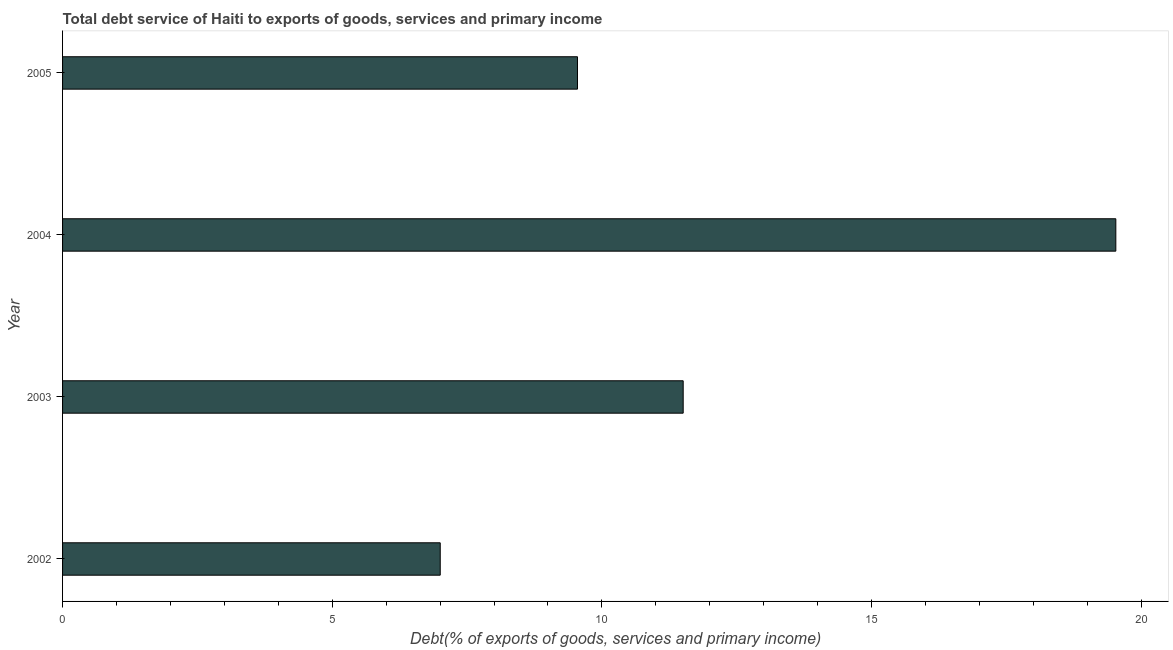Does the graph contain any zero values?
Give a very brief answer. No. What is the title of the graph?
Ensure brevity in your answer.  Total debt service of Haiti to exports of goods, services and primary income. What is the label or title of the X-axis?
Make the answer very short. Debt(% of exports of goods, services and primary income). What is the label or title of the Y-axis?
Give a very brief answer. Year. What is the total debt service in 2003?
Your response must be concise. 11.51. Across all years, what is the maximum total debt service?
Provide a succinct answer. 19.53. Across all years, what is the minimum total debt service?
Your answer should be very brief. 7. In which year was the total debt service maximum?
Ensure brevity in your answer.  2004. What is the sum of the total debt service?
Offer a very short reply. 47.59. What is the difference between the total debt service in 2002 and 2003?
Ensure brevity in your answer.  -4.5. What is the average total debt service per year?
Offer a terse response. 11.9. What is the median total debt service?
Ensure brevity in your answer.  10.53. In how many years, is the total debt service greater than 15 %?
Keep it short and to the point. 1. Do a majority of the years between 2003 and 2004 (inclusive) have total debt service greater than 1 %?
Your answer should be very brief. Yes. What is the ratio of the total debt service in 2003 to that in 2005?
Keep it short and to the point. 1.21. What is the difference between the highest and the second highest total debt service?
Keep it short and to the point. 8.02. What is the difference between the highest and the lowest total debt service?
Offer a very short reply. 12.53. How many years are there in the graph?
Provide a succinct answer. 4. What is the difference between two consecutive major ticks on the X-axis?
Give a very brief answer. 5. What is the Debt(% of exports of goods, services and primary income) of 2002?
Keep it short and to the point. 7. What is the Debt(% of exports of goods, services and primary income) in 2003?
Offer a very short reply. 11.51. What is the Debt(% of exports of goods, services and primary income) of 2004?
Provide a succinct answer. 19.53. What is the Debt(% of exports of goods, services and primary income) in 2005?
Offer a terse response. 9.55. What is the difference between the Debt(% of exports of goods, services and primary income) in 2002 and 2003?
Give a very brief answer. -4.5. What is the difference between the Debt(% of exports of goods, services and primary income) in 2002 and 2004?
Keep it short and to the point. -12.53. What is the difference between the Debt(% of exports of goods, services and primary income) in 2002 and 2005?
Offer a very short reply. -2.55. What is the difference between the Debt(% of exports of goods, services and primary income) in 2003 and 2004?
Give a very brief answer. -8.02. What is the difference between the Debt(% of exports of goods, services and primary income) in 2003 and 2005?
Keep it short and to the point. 1.96. What is the difference between the Debt(% of exports of goods, services and primary income) in 2004 and 2005?
Your answer should be very brief. 9.98. What is the ratio of the Debt(% of exports of goods, services and primary income) in 2002 to that in 2003?
Ensure brevity in your answer.  0.61. What is the ratio of the Debt(% of exports of goods, services and primary income) in 2002 to that in 2004?
Your response must be concise. 0.36. What is the ratio of the Debt(% of exports of goods, services and primary income) in 2002 to that in 2005?
Ensure brevity in your answer.  0.73. What is the ratio of the Debt(% of exports of goods, services and primary income) in 2003 to that in 2004?
Provide a succinct answer. 0.59. What is the ratio of the Debt(% of exports of goods, services and primary income) in 2003 to that in 2005?
Keep it short and to the point. 1.21. What is the ratio of the Debt(% of exports of goods, services and primary income) in 2004 to that in 2005?
Your response must be concise. 2.04. 